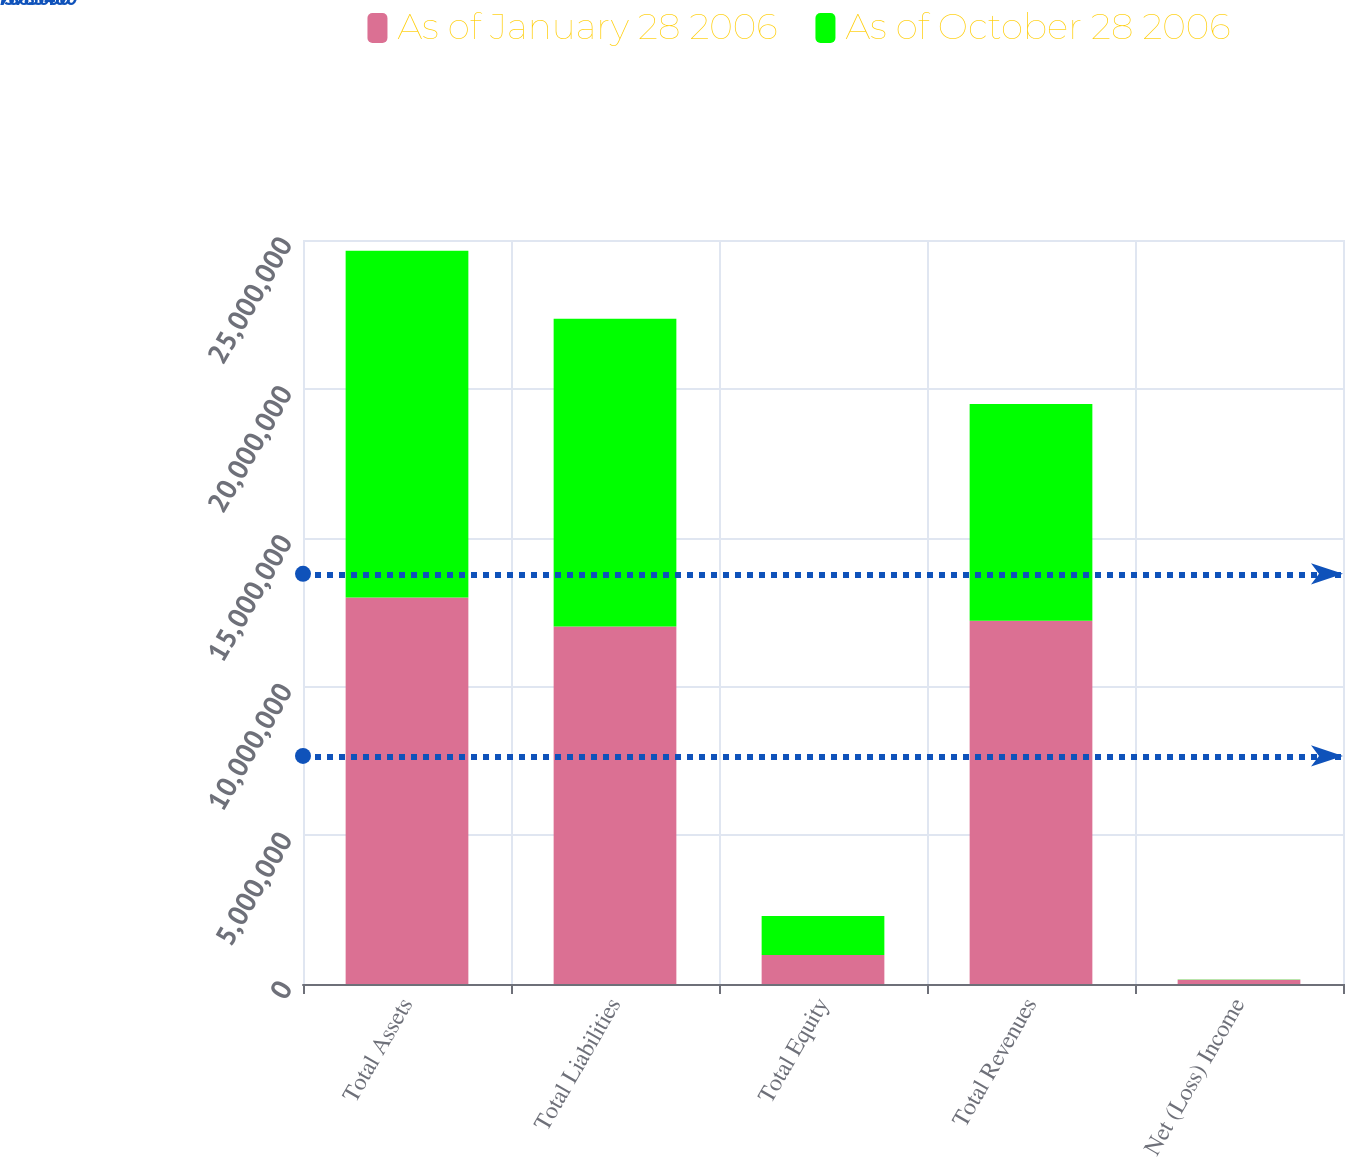Convert chart to OTSL. <chart><loc_0><loc_0><loc_500><loc_500><stacked_bar_chart><ecel><fcel>Total Assets<fcel>Total Liabilities<fcel>Total Equity<fcel>Total Revenues<fcel>Net (Loss) Income<nl><fcel>As of January 28 2006<fcel>1.2985e+07<fcel>1.201e+07<fcel>975000<fcel>1.2205e+07<fcel>143000<nl><fcel>As of October 28 2006<fcel>1.1655e+07<fcel>1.0347e+07<fcel>1.308e+06<fcel>7.281e+06<fcel>8000<nl></chart> 